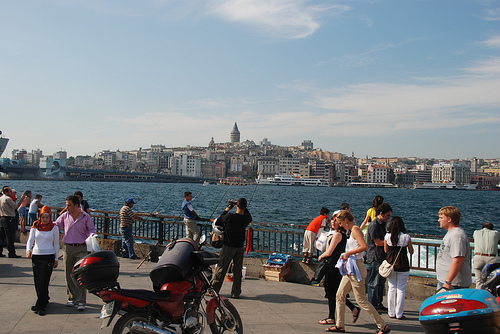<image>
Can you confirm if the carrier is in the river? No. The carrier is not contained within the river. These objects have a different spatial relationship. 